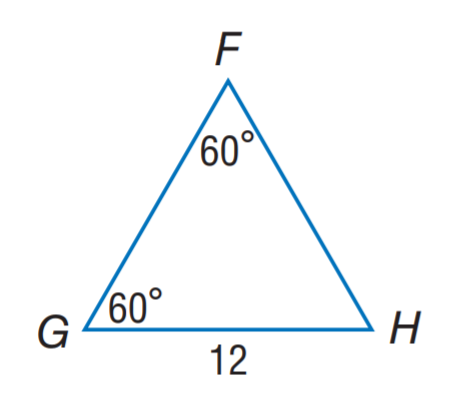Question: Find F H.
Choices:
A. 8
B. 10
C. 12
D. 60
Answer with the letter. Answer: C 